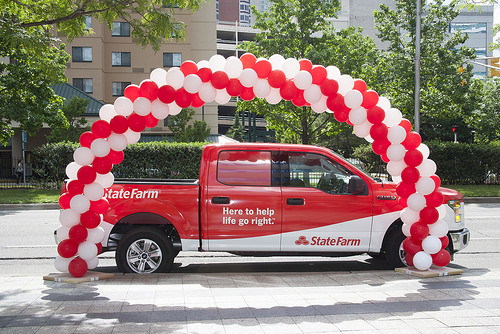<image>
Is there a balloons under the red truck? No. The balloons is not positioned under the red truck. The vertical relationship between these objects is different. Is there a balloon under the truck? No. The balloon is not positioned under the truck. The vertical relationship between these objects is different. 